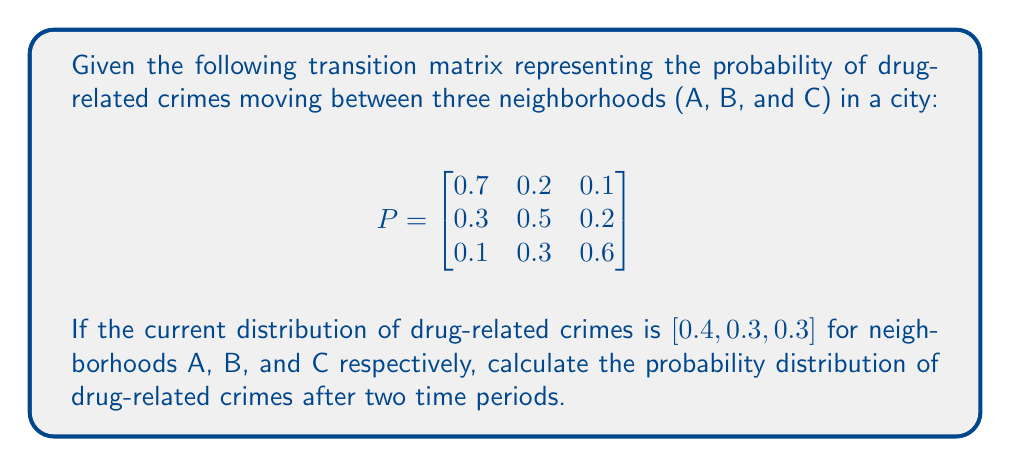Give your solution to this math problem. To solve this problem, we'll use matrix multiplication. Let's break it down step-by-step:

1) Let $v_0 = [0.4, 0.3, 0.3]$ be the initial distribution vector.

2) To find the distribution after one time period, we multiply $v_0$ by $P$:

   $v_1 = v_0P = [0.4, 0.3, 0.3] \begin{bmatrix}
   0.7 & 0.2 & 0.1 \\
   0.3 & 0.5 & 0.2 \\
   0.1 & 0.3 & 0.6
   \end{bmatrix}$

3) Calculating $v_1$:
   $v_1 = [0.4(0.7) + 0.3(0.3) + 0.3(0.1), 0.4(0.2) + 0.3(0.5) + 0.3(0.3), 0.4(0.1) + 0.3(0.2) + 0.3(0.6)]$
   $v_1 = [0.41, 0.31, 0.28]$

4) To find the distribution after two time periods, we multiply $v_1$ by $P$ again:

   $v_2 = v_1P = [0.41, 0.31, 0.28] \begin{bmatrix}
   0.7 & 0.2 & 0.1 \\
   0.3 & 0.5 & 0.2 \\
   0.1 & 0.3 & 0.6
   \end{bmatrix}$

5) Calculating $v_2$:
   $v_2 = [0.41(0.7) + 0.31(0.3) + 0.28(0.1), 0.41(0.2) + 0.31(0.5) + 0.28(0.3), 0.41(0.1) + 0.31(0.2) + 0.28(0.6)]$
   $v_2 = [0.416, 0.313, 0.271]$

Therefore, after two time periods, the probability distribution of drug-related crimes in neighborhoods A, B, and C is approximately [0.416, 0.313, 0.271].
Answer: $[0.416, 0.313, 0.271]$ 